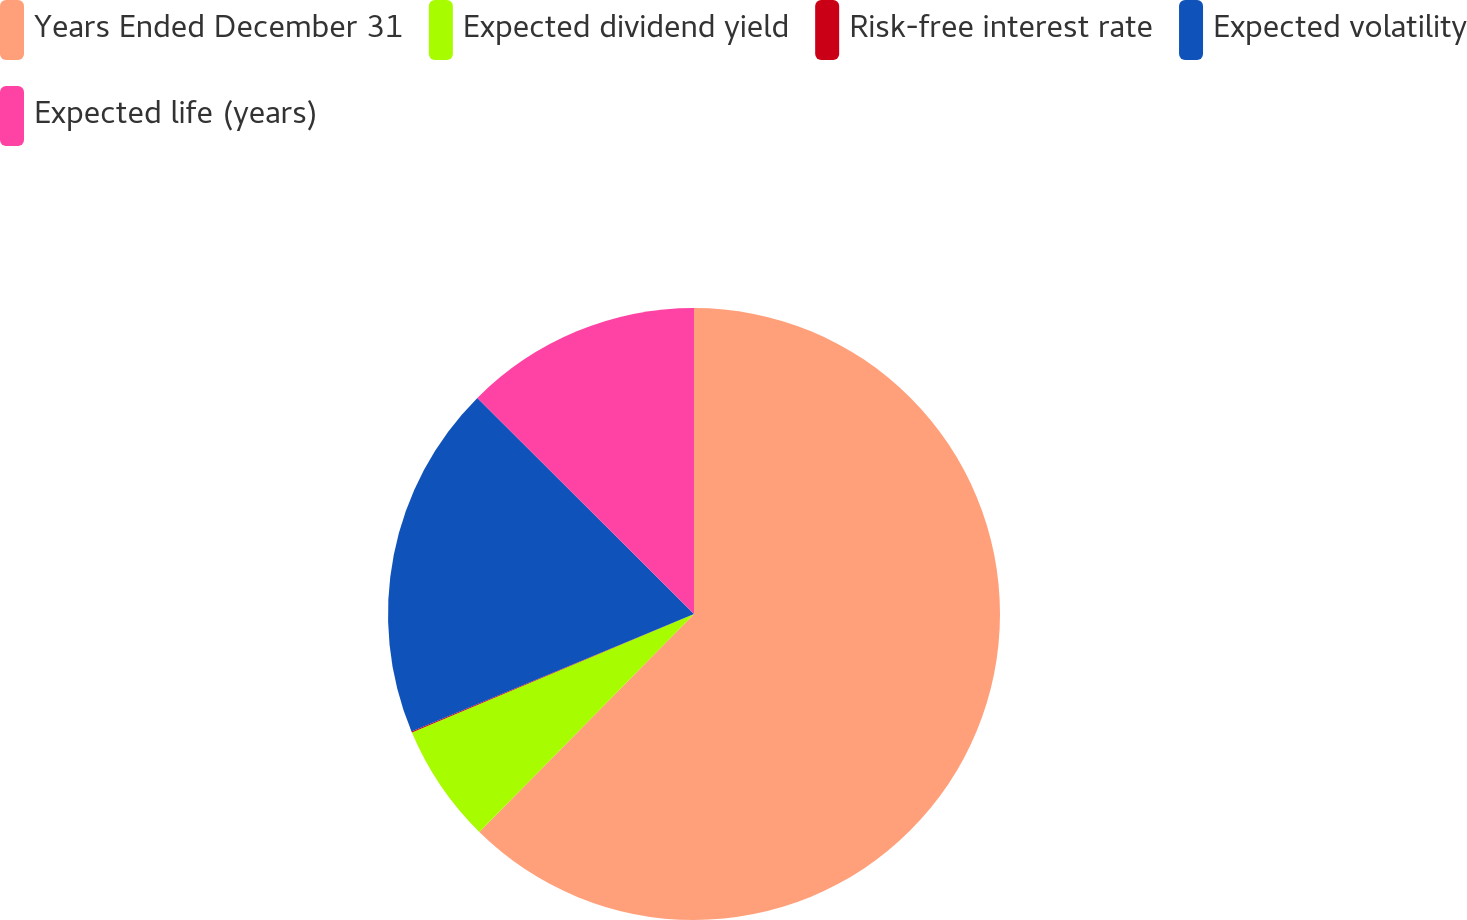Convert chart to OTSL. <chart><loc_0><loc_0><loc_500><loc_500><pie_chart><fcel>Years Ended December 31<fcel>Expected dividend yield<fcel>Risk-free interest rate<fcel>Expected volatility<fcel>Expected life (years)<nl><fcel>62.37%<fcel>6.29%<fcel>0.06%<fcel>18.75%<fcel>12.52%<nl></chart> 